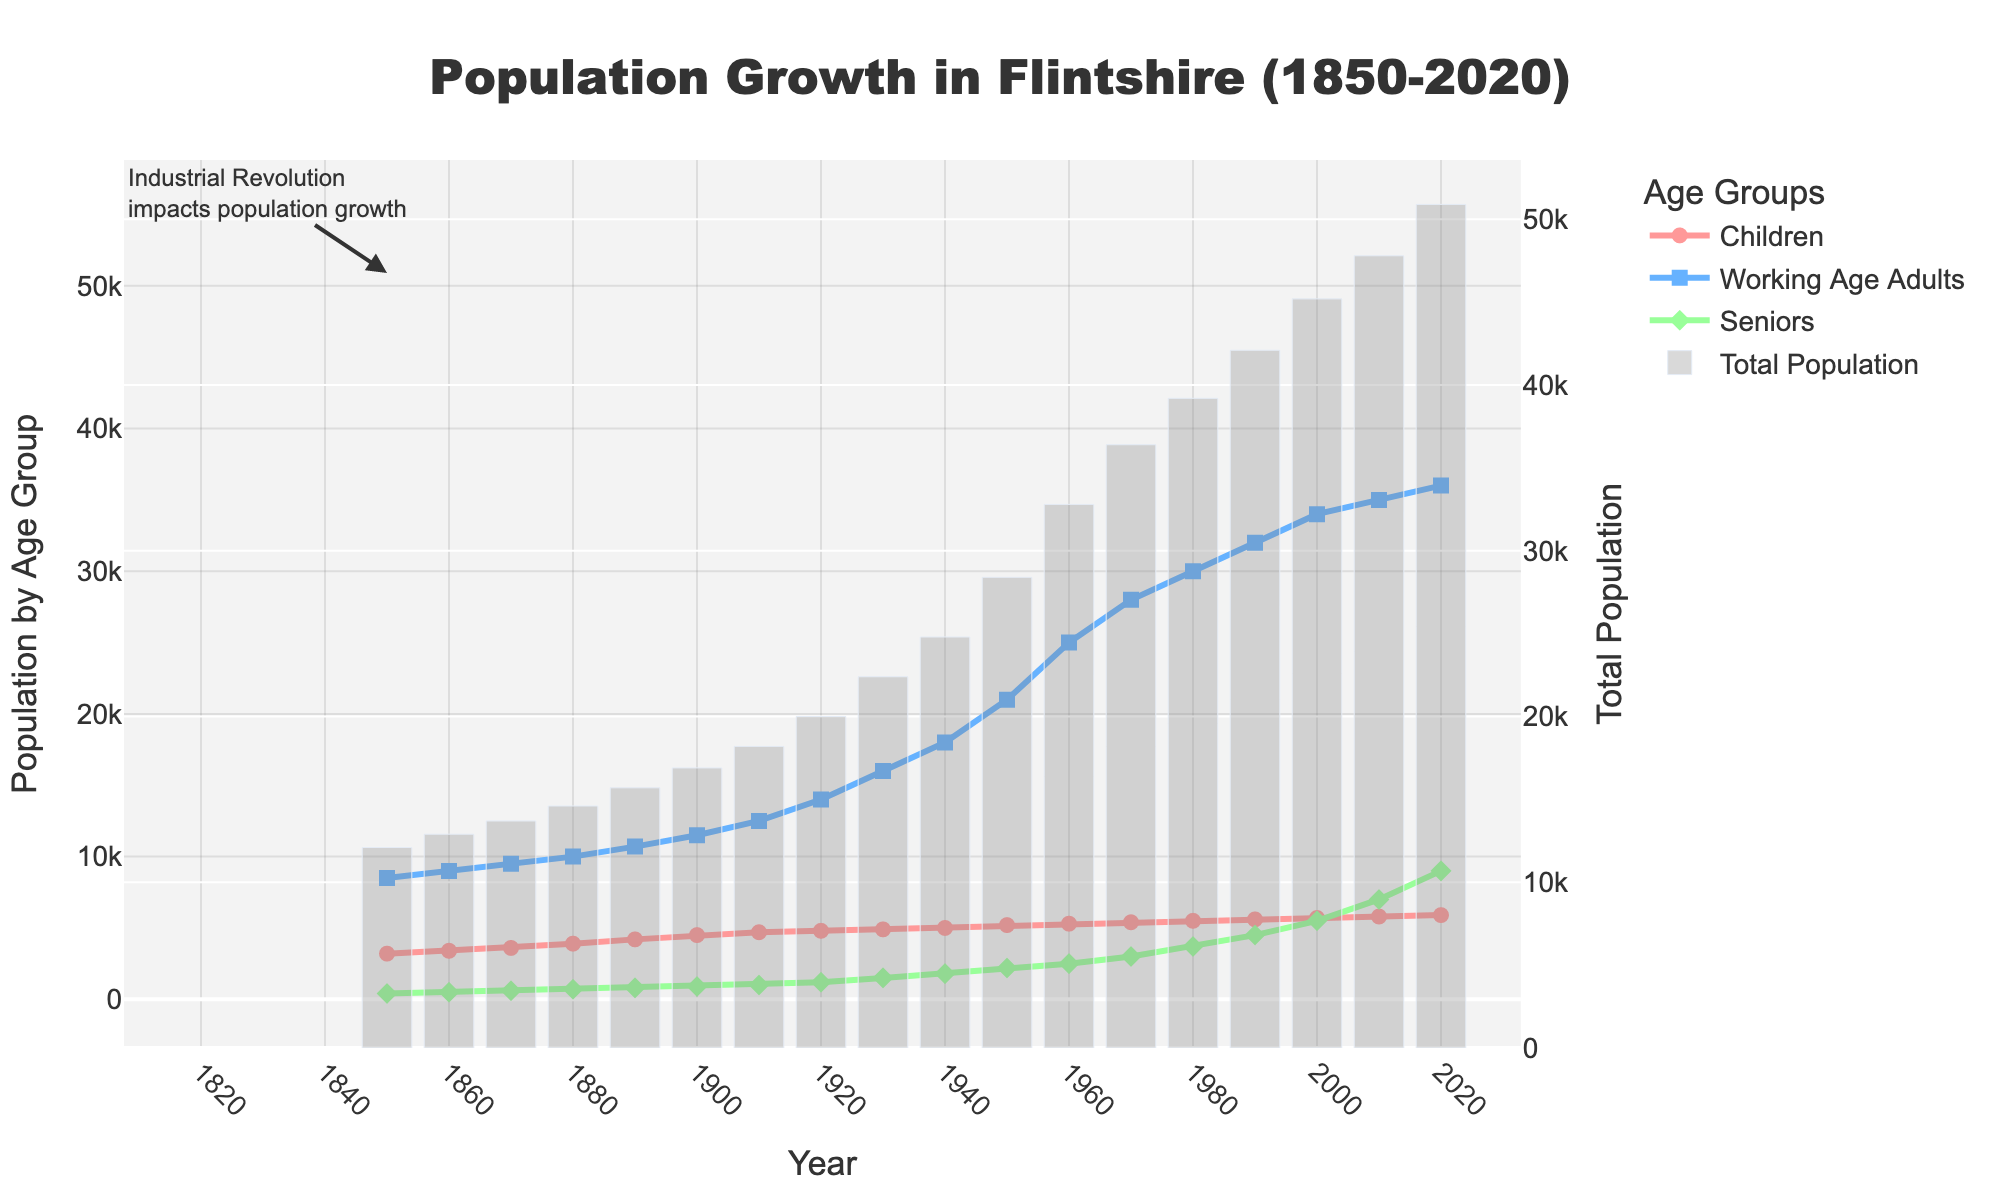what are the age groups represented in the plot? The plot represents three age groups: children, working-age adults, and seniors. This is shown by the separate lines and legends depicting each age group.
Answer: children, working-age adults, seniors what is the highest population recorded for children, and in which year? From the plot, the line representing children peaks at 5900 in the year 2020. This can be observed as the highest point of the line labeled for children.
Answer: 5900 in 2020 what is the approximate year when the seniors' population surpassed 5000? According to the plot, the senior population crosses the 5000 mark around the year 2000. This can be inferred by following the line for seniors until it goes above the 5000 level on the y-axis.
Answer: around 2000 how has the population of working-age adults changed from 1910 to 1920? The population of working-age adults increased from 12500 in 1910 to 14000 in 1920. This is seen as an upward movement in the line for working-age adults between these years.
Answer: increased from 12500 to 14000 compare the total population in the year 1950 to the total population in the year 1980. In 1950, the total population was the sum of children (5200), working-age adults (21000), and seniors (2200), which equals 28400. In 1980, the total population was the sum of children (5500), working-age adults (30000), and seniors (3700), which equals 39200. Therefore, the total population increased from 28400 in 1950 to 39200 in 1980.
Answer: increased from 28400 to 39200 during which decade was the fastest growth observed in the population of working-age adults? The fastest growth in the population of working-age adults is observed between 1910 and 1920. The number increased from 12500 to 14000 in this decade, showing the steepest incline in the plot's line for working-age adults.
Answer: 1910-1920 what can be inferred from the plot about the impact of the industrial revolution on Flintshire’s population growth? The annotation on the plot at the starting point (1850) suggests the Industrial Revolution impacted Flintshire’s population growth. We see a steady increase in all age groups, indicating industrial developments likely fostered population growth through better employment and living standards.
Answer: increased population growth which age group had the highest rate of change from 2000 to 2020? From 2000 to 2020, the seniors' population shows the highest rate of change, increasing from 5500 to 9000. This can be observed visually by the steep upward trajectory of the line for seniors.
Answer: seniors is there any period where the population growth of seniors was relatively stagnant? Yes, the period between 1850 and 1900 shows relatively stagnant growth for the seniors' population. The line for seniors during this period remains relatively flat, indicating little change in the population.
Answer: 1850-1900 how is the total population depicted in the plot, and why is this visualization technique useful? The total population is depicted using a bar chart on the secondary y-axis. This technique is useful because it provides a clear view of both the individual age group trends and the overall population trend, offering a comprehensive understanding of population changes.
Answer: bar chart and secondary y-axis 